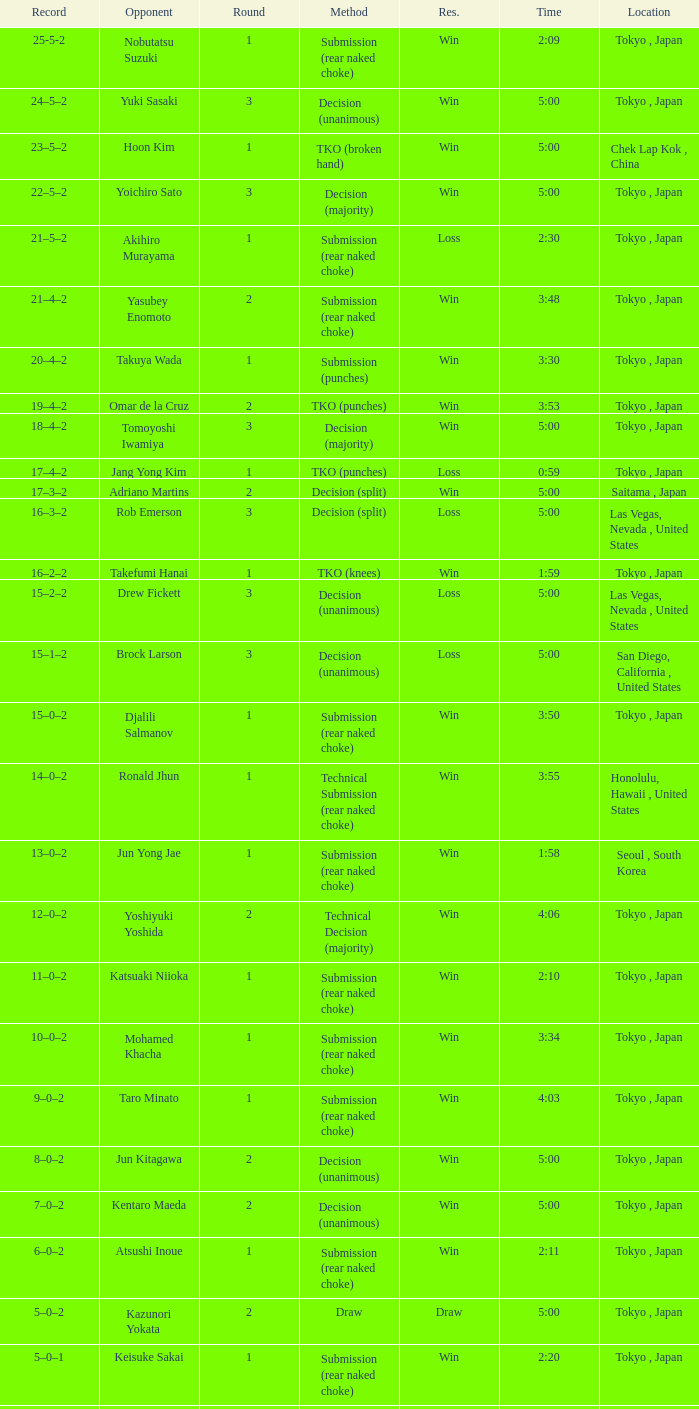Can you parse all the data within this table? {'header': ['Record', 'Opponent', 'Round', 'Method', 'Res.', 'Time', 'Location'], 'rows': [['25-5-2', 'Nobutatsu Suzuki', '1', 'Submission (rear naked choke)', 'Win', '2:09', 'Tokyo , Japan'], ['24–5–2', 'Yuki Sasaki', '3', 'Decision (unanimous)', 'Win', '5:00', 'Tokyo , Japan'], ['23–5–2', 'Hoon Kim', '1', 'TKO (broken hand)', 'Win', '5:00', 'Chek Lap Kok , China'], ['22–5–2', 'Yoichiro Sato', '3', 'Decision (majority)', 'Win', '5:00', 'Tokyo , Japan'], ['21–5–2', 'Akihiro Murayama', '1', 'Submission (rear naked choke)', 'Loss', '2:30', 'Tokyo , Japan'], ['21–4–2', 'Yasubey Enomoto', '2', 'Submission (rear naked choke)', 'Win', '3:48', 'Tokyo , Japan'], ['20–4–2', 'Takuya Wada', '1', 'Submission (punches)', 'Win', '3:30', 'Tokyo , Japan'], ['19–4–2', 'Omar de la Cruz', '2', 'TKO (punches)', 'Win', '3:53', 'Tokyo , Japan'], ['18–4–2', 'Tomoyoshi Iwamiya', '3', 'Decision (majority)', 'Win', '5:00', 'Tokyo , Japan'], ['17–4–2', 'Jang Yong Kim', '1', 'TKO (punches)', 'Loss', '0:59', 'Tokyo , Japan'], ['17–3–2', 'Adriano Martins', '2', 'Decision (split)', 'Win', '5:00', 'Saitama , Japan'], ['16–3–2', 'Rob Emerson', '3', 'Decision (split)', 'Loss', '5:00', 'Las Vegas, Nevada , United States'], ['16–2–2', 'Takefumi Hanai', '1', 'TKO (knees)', 'Win', '1:59', 'Tokyo , Japan'], ['15–2–2', 'Drew Fickett', '3', 'Decision (unanimous)', 'Loss', '5:00', 'Las Vegas, Nevada , United States'], ['15–1–2', 'Brock Larson', '3', 'Decision (unanimous)', 'Loss', '5:00', 'San Diego, California , United States'], ['15–0–2', 'Djalili Salmanov', '1', 'Submission (rear naked choke)', 'Win', '3:50', 'Tokyo , Japan'], ['14–0–2', 'Ronald Jhun', '1', 'Technical Submission (rear naked choke)', 'Win', '3:55', 'Honolulu, Hawaii , United States'], ['13–0–2', 'Jun Yong Jae', '1', 'Submission (rear naked choke)', 'Win', '1:58', 'Seoul , South Korea'], ['12–0–2', 'Yoshiyuki Yoshida', '2', 'Technical Decision (majority)', 'Win', '4:06', 'Tokyo , Japan'], ['11–0–2', 'Katsuaki Niioka', '1', 'Submission (rear naked choke)', 'Win', '2:10', 'Tokyo , Japan'], ['10–0–2', 'Mohamed Khacha', '1', 'Submission (rear naked choke)', 'Win', '3:34', 'Tokyo , Japan'], ['9–0–2', 'Taro Minato', '1', 'Submission (rear naked choke)', 'Win', '4:03', 'Tokyo , Japan'], ['8–0–2', 'Jun Kitagawa', '2', 'Decision (unanimous)', 'Win', '5:00', 'Tokyo , Japan'], ['7–0–2', 'Kentaro Maeda', '2', 'Decision (unanimous)', 'Win', '5:00', 'Tokyo , Japan'], ['6–0–2', 'Atsushi Inoue', '1', 'Submission (rear naked choke)', 'Win', '2:11', 'Tokyo , Japan'], ['5–0–2', 'Kazunori Yokata', '2', 'Draw', 'Draw', '5:00', 'Tokyo , Japan'], ['5–0–1', 'Keisuke Sakai', '1', 'Submission (rear naked choke)', 'Win', '2:20', 'Tokyo , Japan'], ['4–0–1', 'Ichiro Kanai', '2', 'Decision (unanimous)', 'Win', '5:00', 'Tokyo , Japan'], ['3–0–1', 'Daisuke Nakamura', '2', 'Decision (unanimous)', 'Win', '5:00', 'Tokyo , Japan'], ['2–0–1', 'Ichiro Kanai', '2', 'Draw', 'Draw', '5:00', 'Tokyo , Japan'], ['2–0', 'Kenta Omori', '1', 'Submission (triangle choke)', 'Win', '7:44', 'Tokyo , Japan'], ['1–0', 'Tomohito Tanizaki', '1', 'TKO (punches)', 'Win', '0:33', 'Tokyo , Japan']]} What method had Adriano Martins as an opponent and a time of 5:00? Decision (split). 